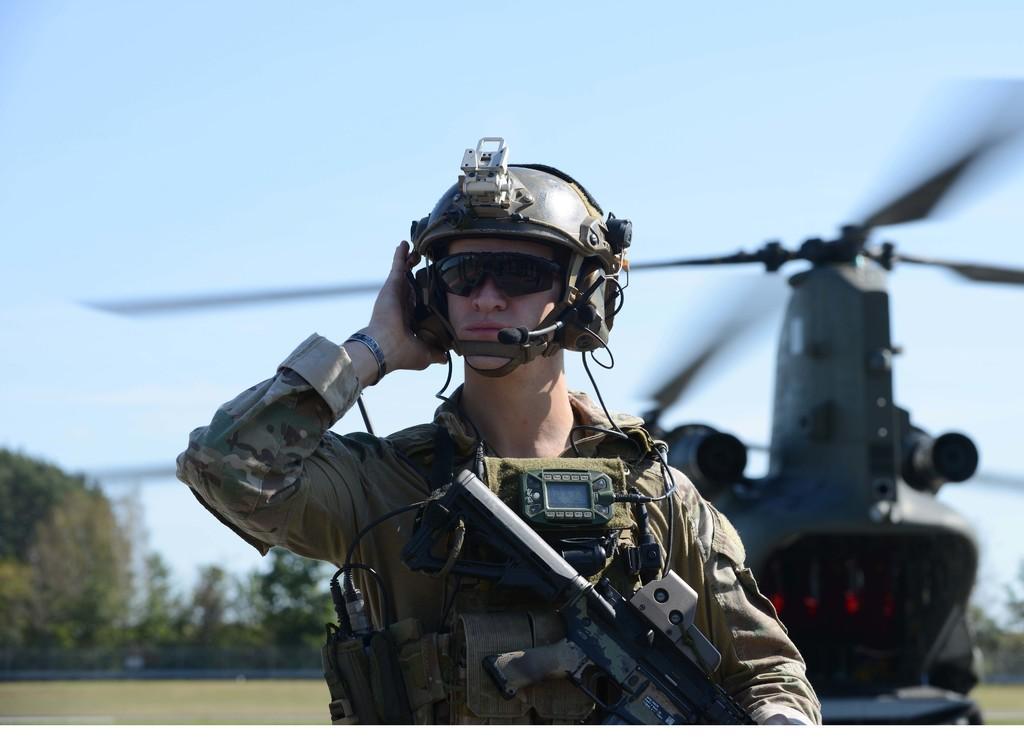Can you describe this image briefly? In this image in front there is a person holding the gun. Behind him there is a helicopter. In the background of the image there is a metal fence. There are trees and sky. At the bottom of the image there is grass on the surface. 